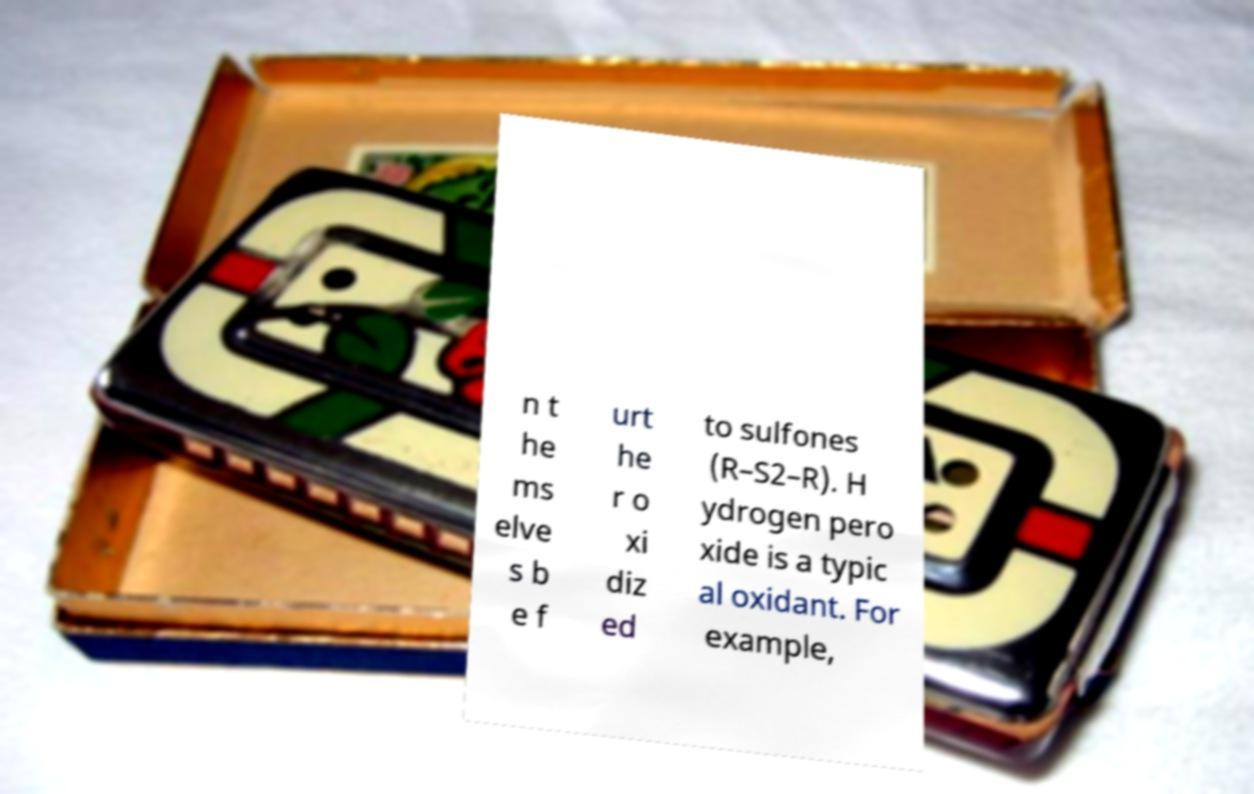Can you accurately transcribe the text from the provided image for me? n t he ms elve s b e f urt he r o xi diz ed to sulfones (R–S2–R). H ydrogen pero xide is a typic al oxidant. For example, 